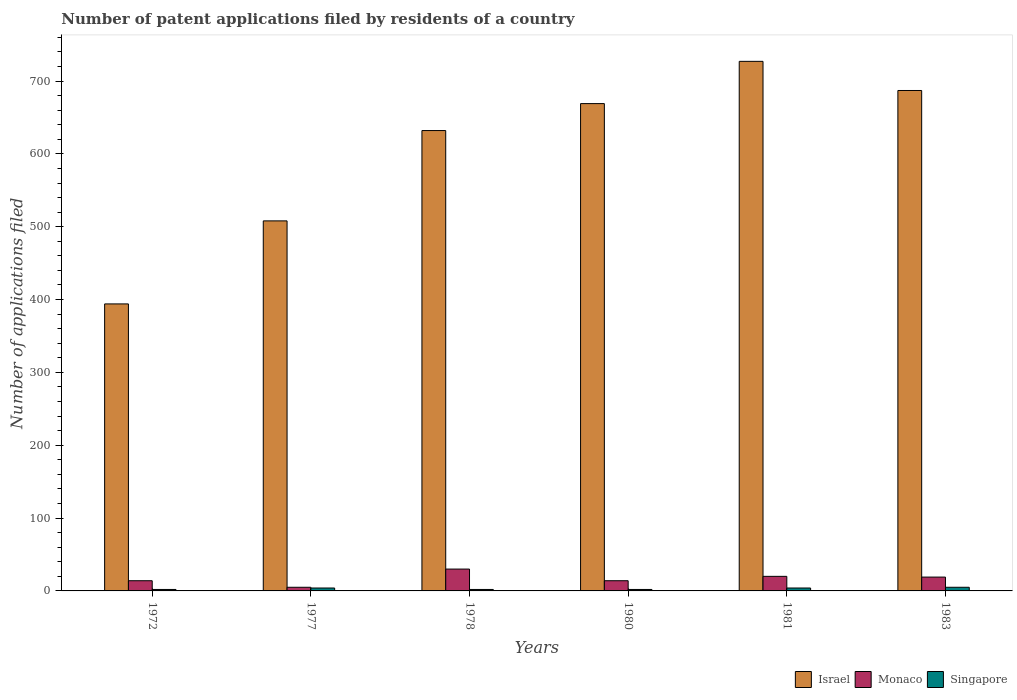Are the number of bars on each tick of the X-axis equal?
Offer a terse response. Yes. How many bars are there on the 3rd tick from the left?
Your response must be concise. 3. What is the label of the 3rd group of bars from the left?
Keep it short and to the point. 1978. Across all years, what is the minimum number of applications filed in Israel?
Ensure brevity in your answer.  394. In which year was the number of applications filed in Monaco maximum?
Ensure brevity in your answer.  1978. In which year was the number of applications filed in Singapore minimum?
Your answer should be compact. 1972. What is the total number of applications filed in Monaco in the graph?
Offer a very short reply. 102. What is the difference between the number of applications filed in Israel in 1980 and that in 1981?
Your response must be concise. -58. What is the average number of applications filed in Israel per year?
Your answer should be very brief. 602.83. In the year 1972, what is the difference between the number of applications filed in Singapore and number of applications filed in Monaco?
Provide a succinct answer. -12. What is the ratio of the number of applications filed in Monaco in 1972 to that in 1983?
Your answer should be compact. 0.74. What is the difference between the highest and the lowest number of applications filed in Israel?
Provide a succinct answer. 333. Is the sum of the number of applications filed in Singapore in 1972 and 1977 greater than the maximum number of applications filed in Israel across all years?
Your answer should be very brief. No. What does the 2nd bar from the left in 1972 represents?
Your answer should be compact. Monaco. Is it the case that in every year, the sum of the number of applications filed in Monaco and number of applications filed in Israel is greater than the number of applications filed in Singapore?
Keep it short and to the point. Yes. Are all the bars in the graph horizontal?
Keep it short and to the point. No. What is the difference between two consecutive major ticks on the Y-axis?
Your answer should be very brief. 100. Does the graph contain grids?
Your response must be concise. No. What is the title of the graph?
Your answer should be compact. Number of patent applications filed by residents of a country. Does "Rwanda" appear as one of the legend labels in the graph?
Keep it short and to the point. No. What is the label or title of the X-axis?
Ensure brevity in your answer.  Years. What is the label or title of the Y-axis?
Provide a succinct answer. Number of applications filed. What is the Number of applications filed in Israel in 1972?
Provide a short and direct response. 394. What is the Number of applications filed of Israel in 1977?
Give a very brief answer. 508. What is the Number of applications filed in Israel in 1978?
Provide a succinct answer. 632. What is the Number of applications filed of Monaco in 1978?
Ensure brevity in your answer.  30. What is the Number of applications filed in Singapore in 1978?
Offer a very short reply. 2. What is the Number of applications filed in Israel in 1980?
Ensure brevity in your answer.  669. What is the Number of applications filed in Monaco in 1980?
Offer a terse response. 14. What is the Number of applications filed of Israel in 1981?
Provide a short and direct response. 727. What is the Number of applications filed in Monaco in 1981?
Your answer should be compact. 20. What is the Number of applications filed of Israel in 1983?
Offer a terse response. 687. Across all years, what is the maximum Number of applications filed of Israel?
Your answer should be very brief. 727. Across all years, what is the maximum Number of applications filed of Monaco?
Your answer should be very brief. 30. Across all years, what is the minimum Number of applications filed in Israel?
Your response must be concise. 394. Across all years, what is the minimum Number of applications filed in Singapore?
Make the answer very short. 2. What is the total Number of applications filed in Israel in the graph?
Your response must be concise. 3617. What is the total Number of applications filed in Monaco in the graph?
Provide a short and direct response. 102. What is the difference between the Number of applications filed of Israel in 1972 and that in 1977?
Ensure brevity in your answer.  -114. What is the difference between the Number of applications filed in Israel in 1972 and that in 1978?
Your response must be concise. -238. What is the difference between the Number of applications filed in Israel in 1972 and that in 1980?
Provide a short and direct response. -275. What is the difference between the Number of applications filed of Singapore in 1972 and that in 1980?
Give a very brief answer. 0. What is the difference between the Number of applications filed in Israel in 1972 and that in 1981?
Your answer should be very brief. -333. What is the difference between the Number of applications filed in Israel in 1972 and that in 1983?
Keep it short and to the point. -293. What is the difference between the Number of applications filed in Singapore in 1972 and that in 1983?
Offer a very short reply. -3. What is the difference between the Number of applications filed in Israel in 1977 and that in 1978?
Provide a succinct answer. -124. What is the difference between the Number of applications filed of Monaco in 1977 and that in 1978?
Give a very brief answer. -25. What is the difference between the Number of applications filed in Singapore in 1977 and that in 1978?
Your answer should be compact. 2. What is the difference between the Number of applications filed of Israel in 1977 and that in 1980?
Offer a very short reply. -161. What is the difference between the Number of applications filed in Singapore in 1977 and that in 1980?
Offer a very short reply. 2. What is the difference between the Number of applications filed in Israel in 1977 and that in 1981?
Ensure brevity in your answer.  -219. What is the difference between the Number of applications filed of Singapore in 1977 and that in 1981?
Offer a terse response. 0. What is the difference between the Number of applications filed in Israel in 1977 and that in 1983?
Provide a succinct answer. -179. What is the difference between the Number of applications filed of Singapore in 1977 and that in 1983?
Your answer should be compact. -1. What is the difference between the Number of applications filed in Israel in 1978 and that in 1980?
Provide a short and direct response. -37. What is the difference between the Number of applications filed in Monaco in 1978 and that in 1980?
Your response must be concise. 16. What is the difference between the Number of applications filed of Singapore in 1978 and that in 1980?
Offer a very short reply. 0. What is the difference between the Number of applications filed in Israel in 1978 and that in 1981?
Keep it short and to the point. -95. What is the difference between the Number of applications filed of Singapore in 1978 and that in 1981?
Ensure brevity in your answer.  -2. What is the difference between the Number of applications filed of Israel in 1978 and that in 1983?
Make the answer very short. -55. What is the difference between the Number of applications filed in Singapore in 1978 and that in 1983?
Offer a terse response. -3. What is the difference between the Number of applications filed in Israel in 1980 and that in 1981?
Your answer should be compact. -58. What is the difference between the Number of applications filed in Singapore in 1980 and that in 1981?
Offer a very short reply. -2. What is the difference between the Number of applications filed of Monaco in 1980 and that in 1983?
Your answer should be compact. -5. What is the difference between the Number of applications filed of Singapore in 1980 and that in 1983?
Your response must be concise. -3. What is the difference between the Number of applications filed of Israel in 1981 and that in 1983?
Ensure brevity in your answer.  40. What is the difference between the Number of applications filed in Israel in 1972 and the Number of applications filed in Monaco in 1977?
Provide a short and direct response. 389. What is the difference between the Number of applications filed of Israel in 1972 and the Number of applications filed of Singapore in 1977?
Offer a very short reply. 390. What is the difference between the Number of applications filed of Monaco in 1972 and the Number of applications filed of Singapore in 1977?
Provide a short and direct response. 10. What is the difference between the Number of applications filed in Israel in 1972 and the Number of applications filed in Monaco in 1978?
Your response must be concise. 364. What is the difference between the Number of applications filed of Israel in 1972 and the Number of applications filed of Singapore in 1978?
Make the answer very short. 392. What is the difference between the Number of applications filed of Israel in 1972 and the Number of applications filed of Monaco in 1980?
Your answer should be very brief. 380. What is the difference between the Number of applications filed in Israel in 1972 and the Number of applications filed in Singapore in 1980?
Keep it short and to the point. 392. What is the difference between the Number of applications filed of Israel in 1972 and the Number of applications filed of Monaco in 1981?
Give a very brief answer. 374. What is the difference between the Number of applications filed of Israel in 1972 and the Number of applications filed of Singapore in 1981?
Offer a very short reply. 390. What is the difference between the Number of applications filed of Israel in 1972 and the Number of applications filed of Monaco in 1983?
Your answer should be compact. 375. What is the difference between the Number of applications filed of Israel in 1972 and the Number of applications filed of Singapore in 1983?
Offer a very short reply. 389. What is the difference between the Number of applications filed in Israel in 1977 and the Number of applications filed in Monaco in 1978?
Your answer should be very brief. 478. What is the difference between the Number of applications filed of Israel in 1977 and the Number of applications filed of Singapore in 1978?
Provide a succinct answer. 506. What is the difference between the Number of applications filed of Monaco in 1977 and the Number of applications filed of Singapore in 1978?
Offer a terse response. 3. What is the difference between the Number of applications filed in Israel in 1977 and the Number of applications filed in Monaco in 1980?
Provide a short and direct response. 494. What is the difference between the Number of applications filed in Israel in 1977 and the Number of applications filed in Singapore in 1980?
Make the answer very short. 506. What is the difference between the Number of applications filed in Israel in 1977 and the Number of applications filed in Monaco in 1981?
Your answer should be compact. 488. What is the difference between the Number of applications filed of Israel in 1977 and the Number of applications filed of Singapore in 1981?
Offer a very short reply. 504. What is the difference between the Number of applications filed of Monaco in 1977 and the Number of applications filed of Singapore in 1981?
Provide a succinct answer. 1. What is the difference between the Number of applications filed of Israel in 1977 and the Number of applications filed of Monaco in 1983?
Ensure brevity in your answer.  489. What is the difference between the Number of applications filed in Israel in 1977 and the Number of applications filed in Singapore in 1983?
Your response must be concise. 503. What is the difference between the Number of applications filed in Israel in 1978 and the Number of applications filed in Monaco in 1980?
Your response must be concise. 618. What is the difference between the Number of applications filed of Israel in 1978 and the Number of applications filed of Singapore in 1980?
Provide a succinct answer. 630. What is the difference between the Number of applications filed of Monaco in 1978 and the Number of applications filed of Singapore in 1980?
Your response must be concise. 28. What is the difference between the Number of applications filed in Israel in 1978 and the Number of applications filed in Monaco in 1981?
Offer a terse response. 612. What is the difference between the Number of applications filed of Israel in 1978 and the Number of applications filed of Singapore in 1981?
Your answer should be compact. 628. What is the difference between the Number of applications filed in Israel in 1978 and the Number of applications filed in Monaco in 1983?
Offer a very short reply. 613. What is the difference between the Number of applications filed in Israel in 1978 and the Number of applications filed in Singapore in 1983?
Your answer should be compact. 627. What is the difference between the Number of applications filed in Israel in 1980 and the Number of applications filed in Monaco in 1981?
Your answer should be very brief. 649. What is the difference between the Number of applications filed of Israel in 1980 and the Number of applications filed of Singapore in 1981?
Your answer should be compact. 665. What is the difference between the Number of applications filed in Israel in 1980 and the Number of applications filed in Monaco in 1983?
Your response must be concise. 650. What is the difference between the Number of applications filed of Israel in 1980 and the Number of applications filed of Singapore in 1983?
Your response must be concise. 664. What is the difference between the Number of applications filed in Israel in 1981 and the Number of applications filed in Monaco in 1983?
Your response must be concise. 708. What is the difference between the Number of applications filed of Israel in 1981 and the Number of applications filed of Singapore in 1983?
Provide a short and direct response. 722. What is the difference between the Number of applications filed of Monaco in 1981 and the Number of applications filed of Singapore in 1983?
Offer a terse response. 15. What is the average Number of applications filed in Israel per year?
Your answer should be very brief. 602.83. What is the average Number of applications filed in Monaco per year?
Give a very brief answer. 17. What is the average Number of applications filed of Singapore per year?
Make the answer very short. 3.17. In the year 1972, what is the difference between the Number of applications filed of Israel and Number of applications filed of Monaco?
Ensure brevity in your answer.  380. In the year 1972, what is the difference between the Number of applications filed in Israel and Number of applications filed in Singapore?
Your answer should be compact. 392. In the year 1972, what is the difference between the Number of applications filed of Monaco and Number of applications filed of Singapore?
Ensure brevity in your answer.  12. In the year 1977, what is the difference between the Number of applications filed of Israel and Number of applications filed of Monaco?
Offer a terse response. 503. In the year 1977, what is the difference between the Number of applications filed in Israel and Number of applications filed in Singapore?
Ensure brevity in your answer.  504. In the year 1977, what is the difference between the Number of applications filed of Monaco and Number of applications filed of Singapore?
Your answer should be compact. 1. In the year 1978, what is the difference between the Number of applications filed in Israel and Number of applications filed in Monaco?
Your response must be concise. 602. In the year 1978, what is the difference between the Number of applications filed in Israel and Number of applications filed in Singapore?
Make the answer very short. 630. In the year 1978, what is the difference between the Number of applications filed of Monaco and Number of applications filed of Singapore?
Your response must be concise. 28. In the year 1980, what is the difference between the Number of applications filed in Israel and Number of applications filed in Monaco?
Keep it short and to the point. 655. In the year 1980, what is the difference between the Number of applications filed in Israel and Number of applications filed in Singapore?
Your answer should be compact. 667. In the year 1980, what is the difference between the Number of applications filed of Monaco and Number of applications filed of Singapore?
Ensure brevity in your answer.  12. In the year 1981, what is the difference between the Number of applications filed in Israel and Number of applications filed in Monaco?
Give a very brief answer. 707. In the year 1981, what is the difference between the Number of applications filed of Israel and Number of applications filed of Singapore?
Ensure brevity in your answer.  723. In the year 1981, what is the difference between the Number of applications filed of Monaco and Number of applications filed of Singapore?
Your response must be concise. 16. In the year 1983, what is the difference between the Number of applications filed of Israel and Number of applications filed of Monaco?
Make the answer very short. 668. In the year 1983, what is the difference between the Number of applications filed of Israel and Number of applications filed of Singapore?
Make the answer very short. 682. What is the ratio of the Number of applications filed in Israel in 1972 to that in 1977?
Keep it short and to the point. 0.78. What is the ratio of the Number of applications filed of Israel in 1972 to that in 1978?
Ensure brevity in your answer.  0.62. What is the ratio of the Number of applications filed of Monaco in 1972 to that in 1978?
Ensure brevity in your answer.  0.47. What is the ratio of the Number of applications filed of Israel in 1972 to that in 1980?
Give a very brief answer. 0.59. What is the ratio of the Number of applications filed of Monaco in 1972 to that in 1980?
Your answer should be very brief. 1. What is the ratio of the Number of applications filed of Singapore in 1972 to that in 1980?
Your answer should be compact. 1. What is the ratio of the Number of applications filed of Israel in 1972 to that in 1981?
Give a very brief answer. 0.54. What is the ratio of the Number of applications filed of Monaco in 1972 to that in 1981?
Offer a terse response. 0.7. What is the ratio of the Number of applications filed in Israel in 1972 to that in 1983?
Offer a very short reply. 0.57. What is the ratio of the Number of applications filed in Monaco in 1972 to that in 1983?
Offer a very short reply. 0.74. What is the ratio of the Number of applications filed in Singapore in 1972 to that in 1983?
Give a very brief answer. 0.4. What is the ratio of the Number of applications filed of Israel in 1977 to that in 1978?
Keep it short and to the point. 0.8. What is the ratio of the Number of applications filed in Israel in 1977 to that in 1980?
Offer a very short reply. 0.76. What is the ratio of the Number of applications filed in Monaco in 1977 to that in 1980?
Keep it short and to the point. 0.36. What is the ratio of the Number of applications filed in Israel in 1977 to that in 1981?
Your answer should be compact. 0.7. What is the ratio of the Number of applications filed in Singapore in 1977 to that in 1981?
Offer a very short reply. 1. What is the ratio of the Number of applications filed in Israel in 1977 to that in 1983?
Make the answer very short. 0.74. What is the ratio of the Number of applications filed in Monaco in 1977 to that in 1983?
Make the answer very short. 0.26. What is the ratio of the Number of applications filed in Singapore in 1977 to that in 1983?
Keep it short and to the point. 0.8. What is the ratio of the Number of applications filed of Israel in 1978 to that in 1980?
Your answer should be compact. 0.94. What is the ratio of the Number of applications filed in Monaco in 1978 to that in 1980?
Give a very brief answer. 2.14. What is the ratio of the Number of applications filed in Israel in 1978 to that in 1981?
Ensure brevity in your answer.  0.87. What is the ratio of the Number of applications filed in Monaco in 1978 to that in 1981?
Ensure brevity in your answer.  1.5. What is the ratio of the Number of applications filed of Israel in 1978 to that in 1983?
Your response must be concise. 0.92. What is the ratio of the Number of applications filed of Monaco in 1978 to that in 1983?
Your answer should be very brief. 1.58. What is the ratio of the Number of applications filed of Singapore in 1978 to that in 1983?
Offer a very short reply. 0.4. What is the ratio of the Number of applications filed in Israel in 1980 to that in 1981?
Offer a very short reply. 0.92. What is the ratio of the Number of applications filed of Singapore in 1980 to that in 1981?
Your answer should be compact. 0.5. What is the ratio of the Number of applications filed in Israel in 1980 to that in 1983?
Offer a terse response. 0.97. What is the ratio of the Number of applications filed in Monaco in 1980 to that in 1983?
Make the answer very short. 0.74. What is the ratio of the Number of applications filed in Singapore in 1980 to that in 1983?
Keep it short and to the point. 0.4. What is the ratio of the Number of applications filed in Israel in 1981 to that in 1983?
Your response must be concise. 1.06. What is the ratio of the Number of applications filed in Monaco in 1981 to that in 1983?
Keep it short and to the point. 1.05. What is the difference between the highest and the second highest Number of applications filed of Israel?
Keep it short and to the point. 40. What is the difference between the highest and the second highest Number of applications filed in Monaco?
Ensure brevity in your answer.  10. What is the difference between the highest and the second highest Number of applications filed of Singapore?
Give a very brief answer. 1. What is the difference between the highest and the lowest Number of applications filed in Israel?
Give a very brief answer. 333. What is the difference between the highest and the lowest Number of applications filed of Monaco?
Keep it short and to the point. 25. 